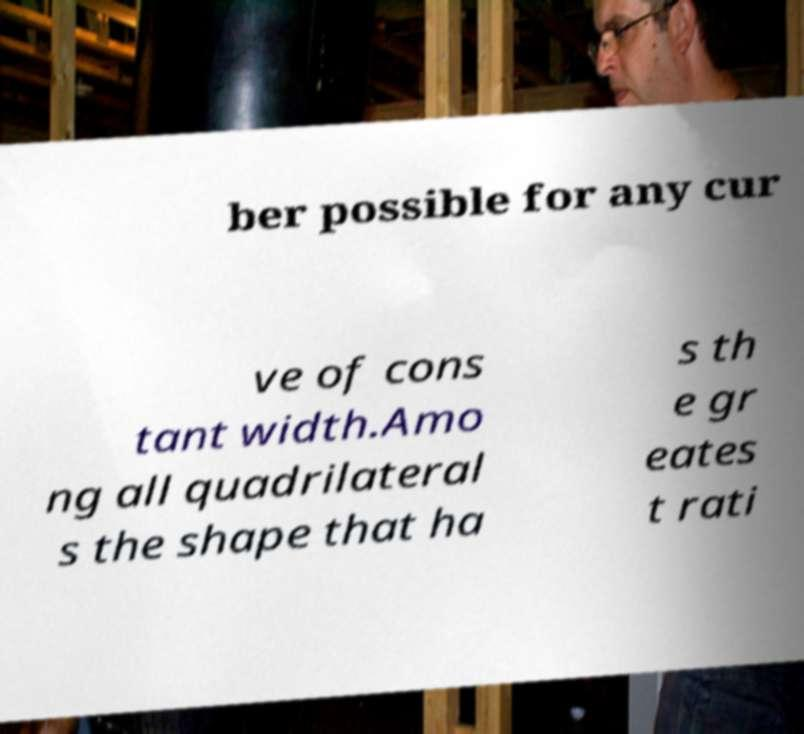For documentation purposes, I need the text within this image transcribed. Could you provide that? ber possible for any cur ve of cons tant width.Amo ng all quadrilateral s the shape that ha s th e gr eates t rati 